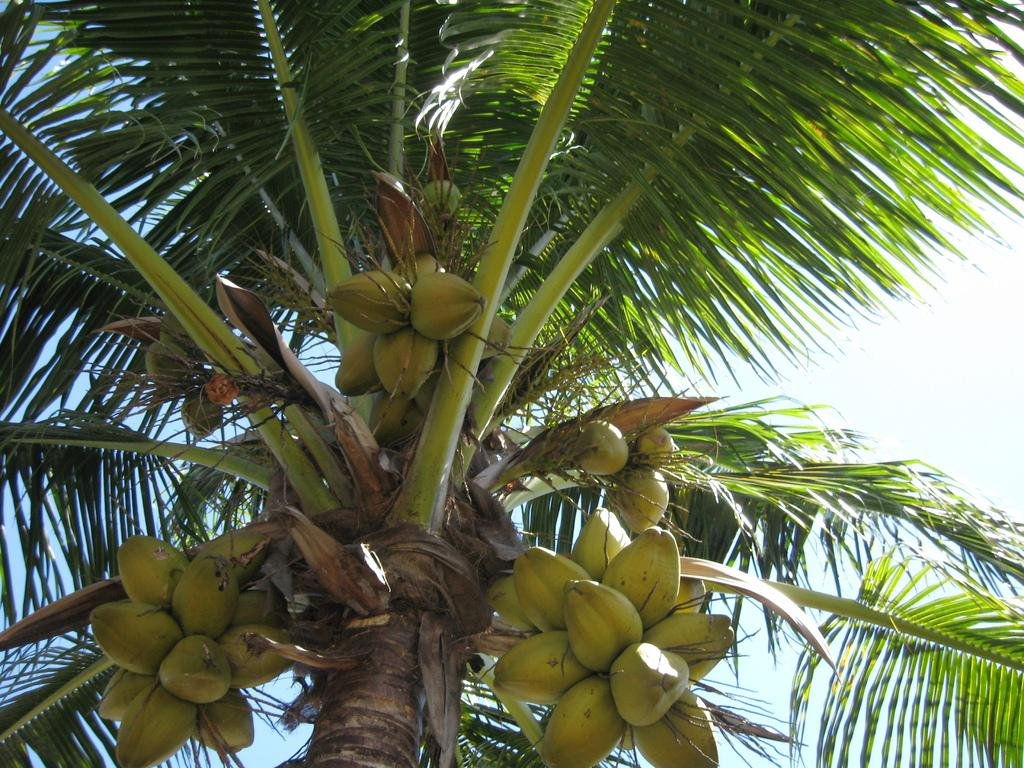What type of tree is in the middle of the image? There is a coconut tree in the middle of the image. How many coconuts can be seen on the tree? There are many coconuts on the tree. Can you see a dock near the coconut tree in the image? There is no dock present in the image; it only features a coconut tree with many coconuts. 